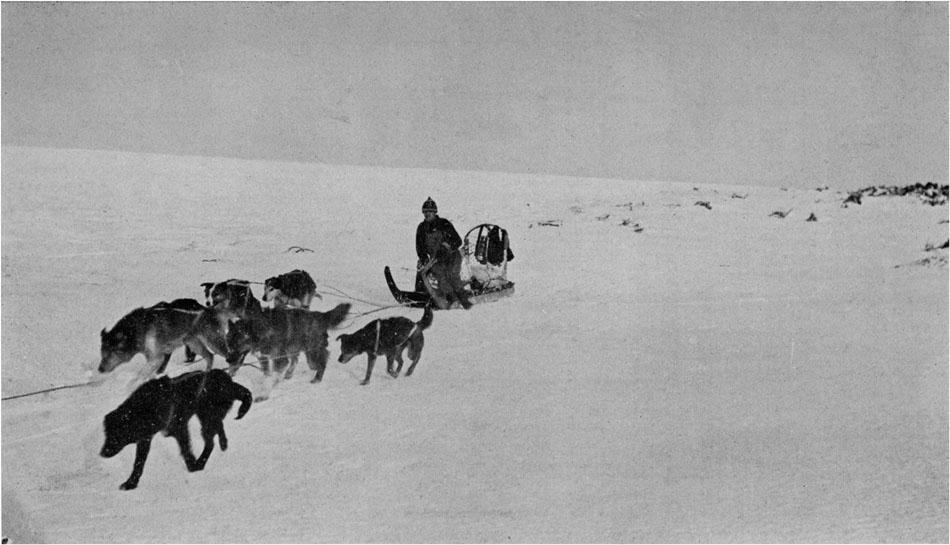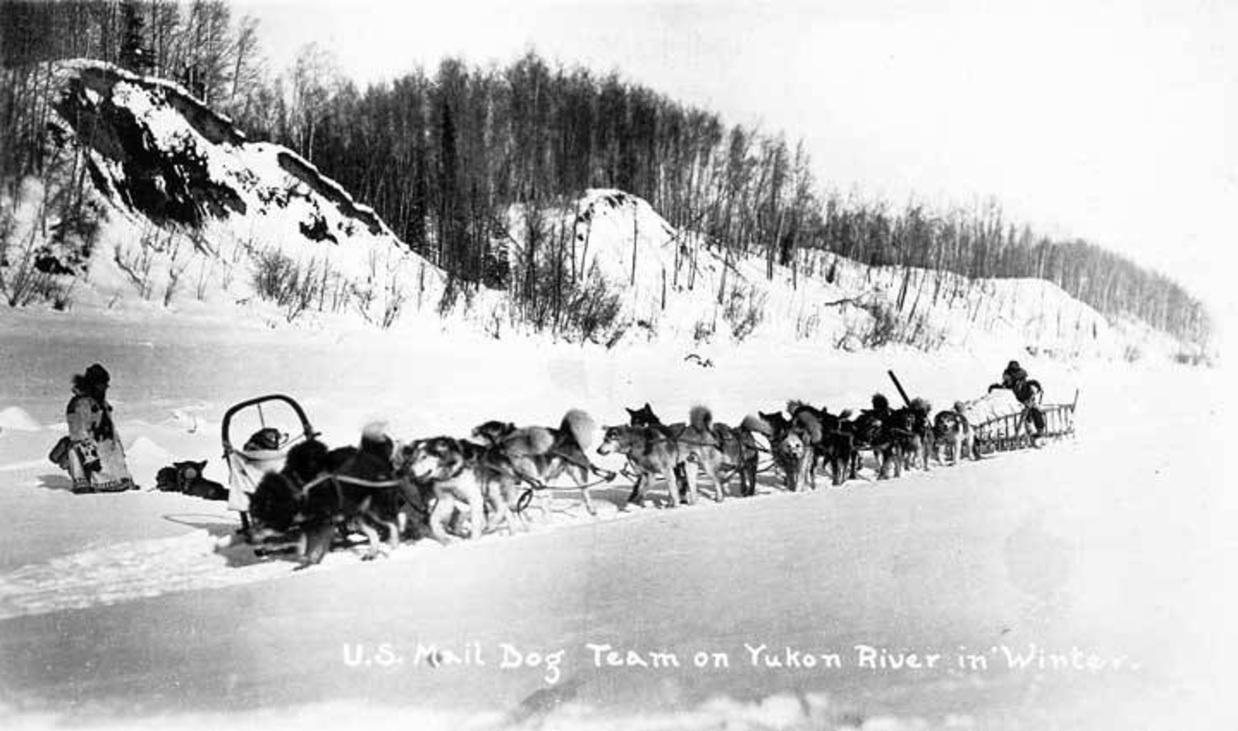The first image is the image on the left, the second image is the image on the right. For the images shown, is this caption "One of the images shows flat terrain with no trees behind the sled dogs." true? Answer yes or no. Yes. The first image is the image on the left, the second image is the image on the right. Considering the images on both sides, is "The lead dog of a sled team aimed leftward is reclining on the snow with both front paws extended and is gazing to the side." valid? Answer yes or no. No. 